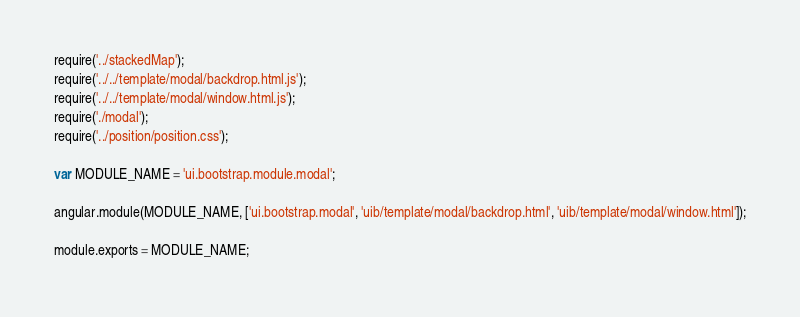<code> <loc_0><loc_0><loc_500><loc_500><_JavaScript_>require('../stackedMap');
require('../../template/modal/backdrop.html.js');
require('../../template/modal/window.html.js');
require('./modal');
require('../position/position.css');

var MODULE_NAME = 'ui.bootstrap.module.modal';

angular.module(MODULE_NAME, ['ui.bootstrap.modal', 'uib/template/modal/backdrop.html', 'uib/template/modal/window.html']);

module.exports = MODULE_NAME;
</code> 